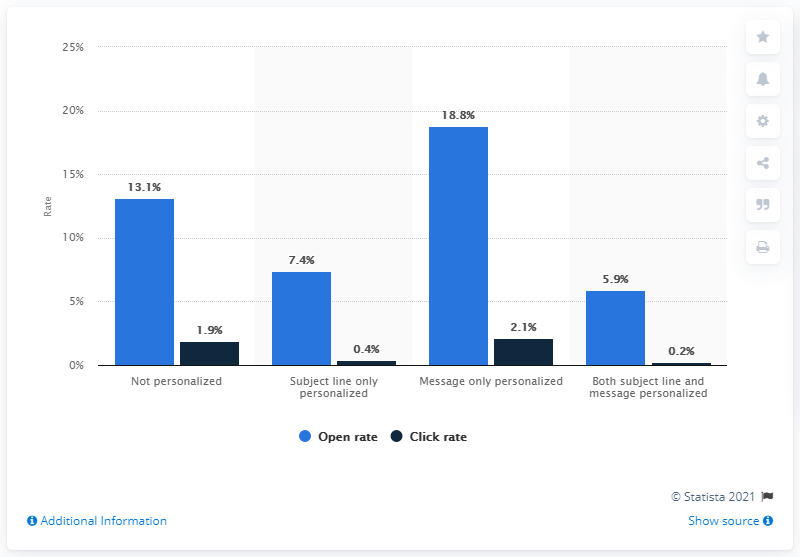Mention a couple of crucial points in this snapshot. The open rate of e-mail messages that were not personalized at all was 13.1%. 